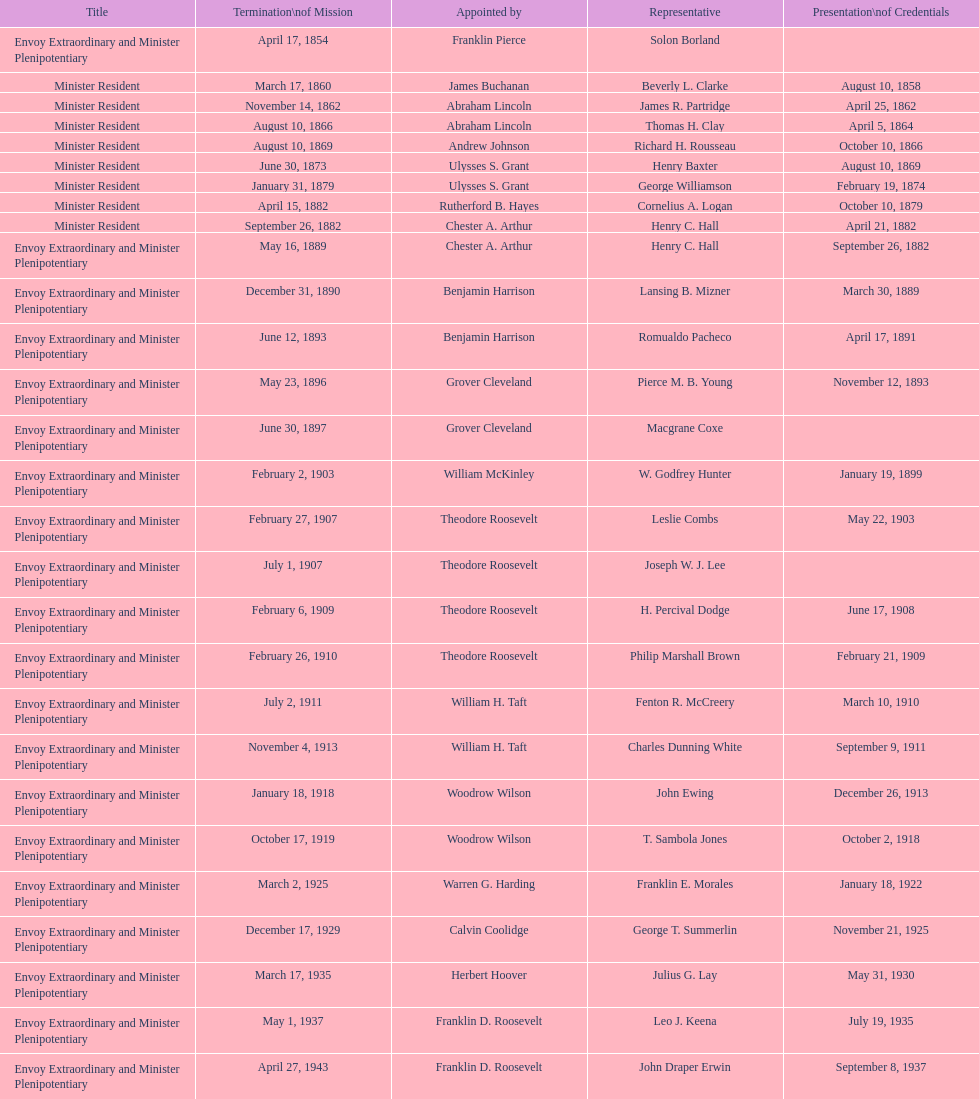How many total representatives have there been? 50. 